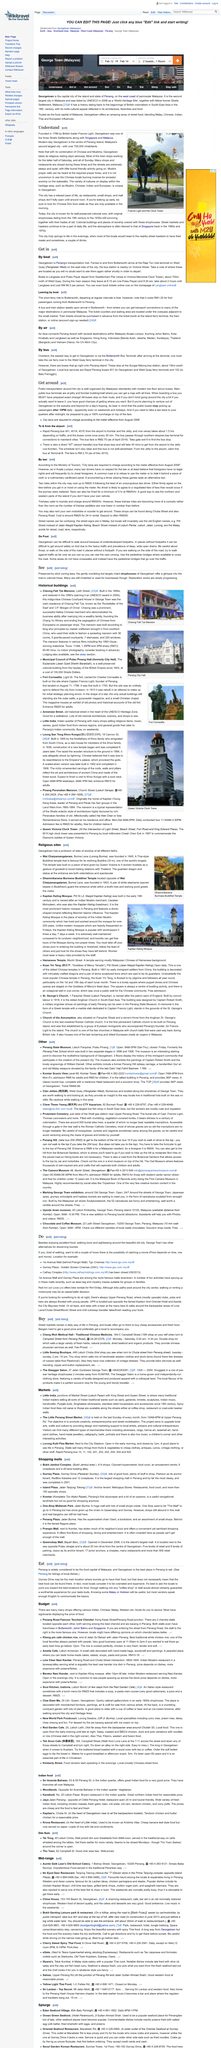Draw attention to some important aspects in this diagram. It is possible to purchase tickets online on the homepage of Langkawi Island, Malaysia. Locals generally view the cuisine on Gurney Drive as overrated and overpriced. AirAsia provides air transportation services that connect Penang International Airport with various locations within Malaysia. The reclining Buddha is 33 meters tall. Burma Lane was founded in 1845. 